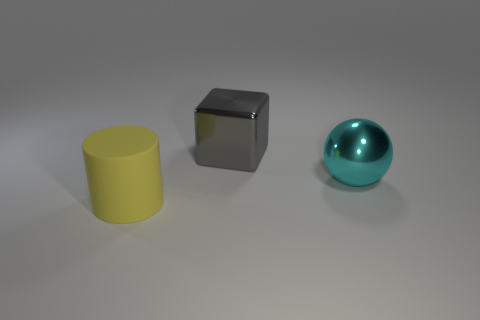The object that is behind the object that is on the right side of the big cube is made of what material?
Provide a succinct answer. Metal. Are there any large things that have the same material as the big cyan sphere?
Provide a short and direct response. Yes. There is a big metal object behind the object to the right of the metallic thing left of the large cyan shiny sphere; what is its shape?
Provide a succinct answer. Cube. What is the yellow cylinder made of?
Your answer should be very brief. Rubber. What color is the big sphere that is made of the same material as the big gray thing?
Give a very brief answer. Cyan. There is a large thing to the right of the big gray thing; are there any gray shiny cubes that are behind it?
Your answer should be compact. Yes. How many other things are the same shape as the gray object?
Offer a terse response. 0. What number of gray metallic blocks are right of the thing that is on the right side of the thing behind the large cyan thing?
Your response must be concise. 0. What is the color of the matte thing?
Ensure brevity in your answer.  Yellow. How many other objects are the same size as the yellow matte thing?
Provide a short and direct response. 2. 